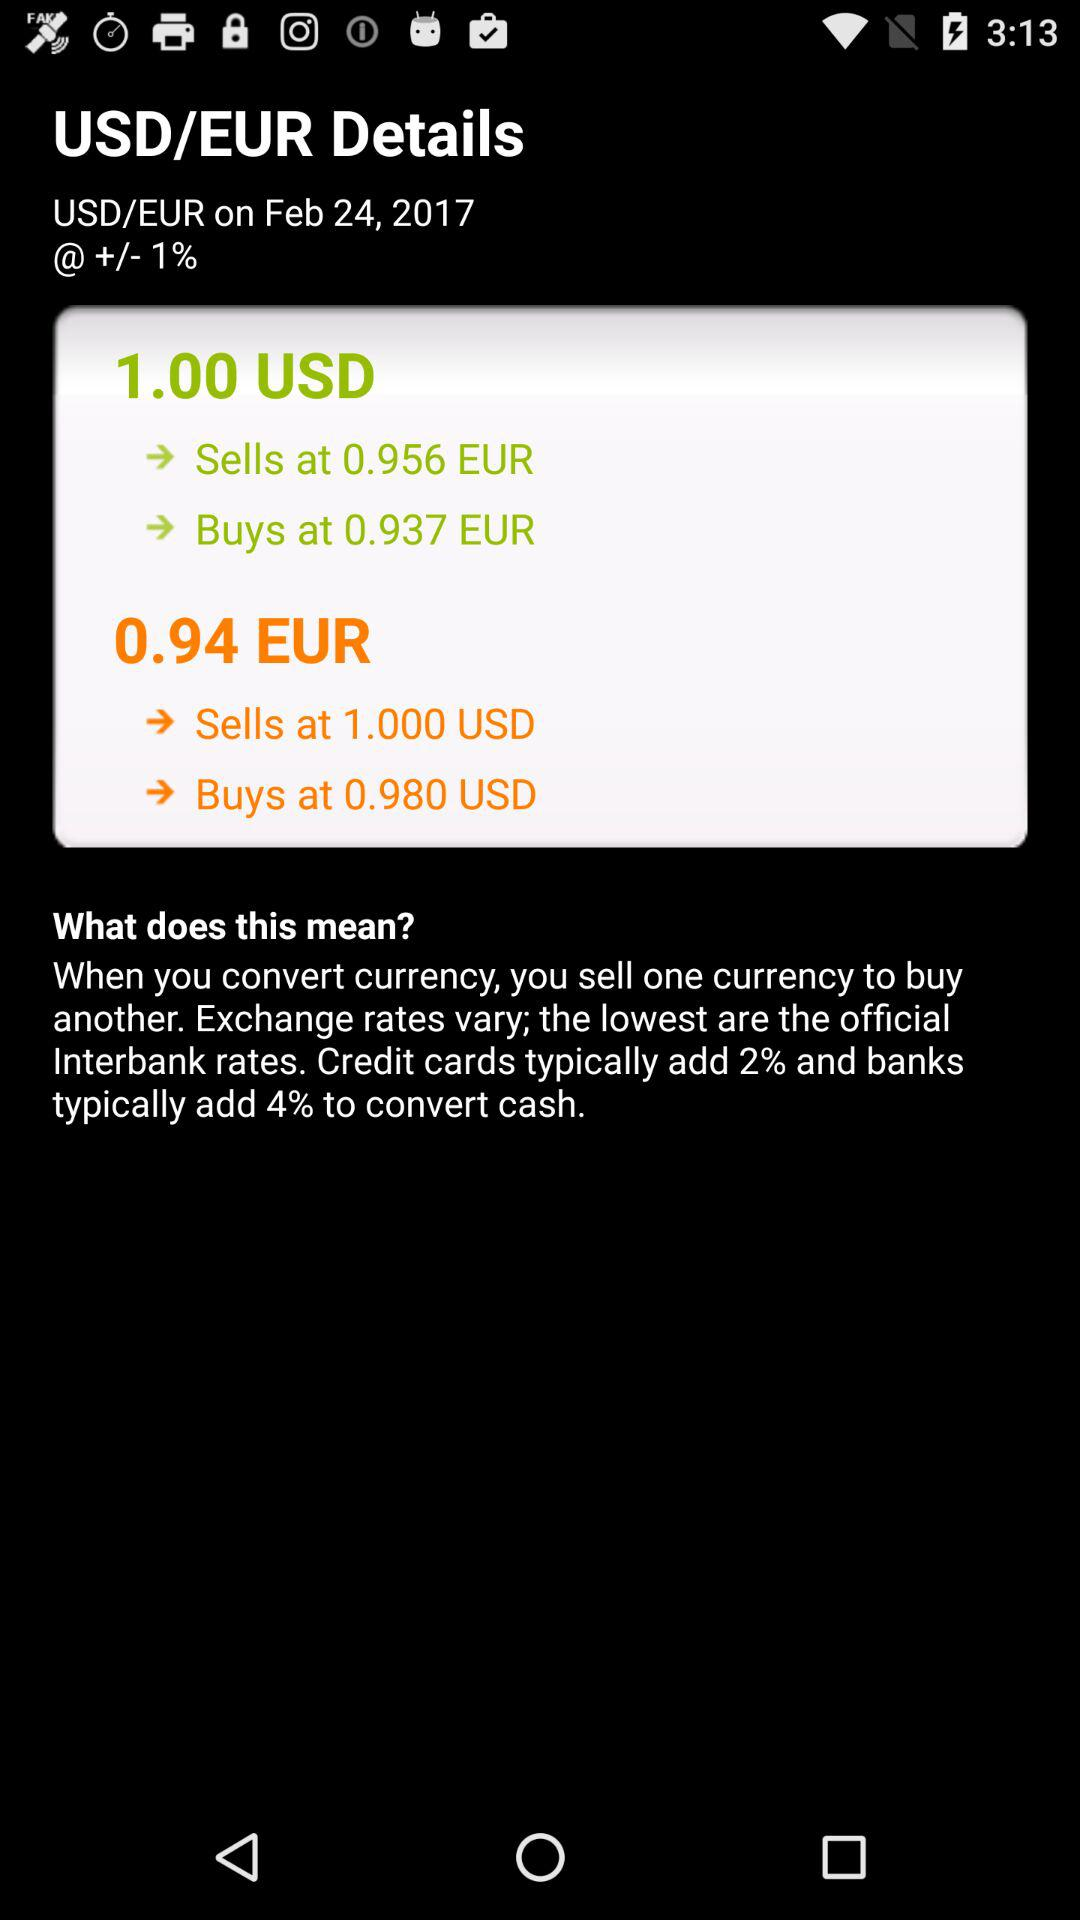When were the USD/EUR details fetched? The USD/EUR details were fetched on February 24, 2017. 